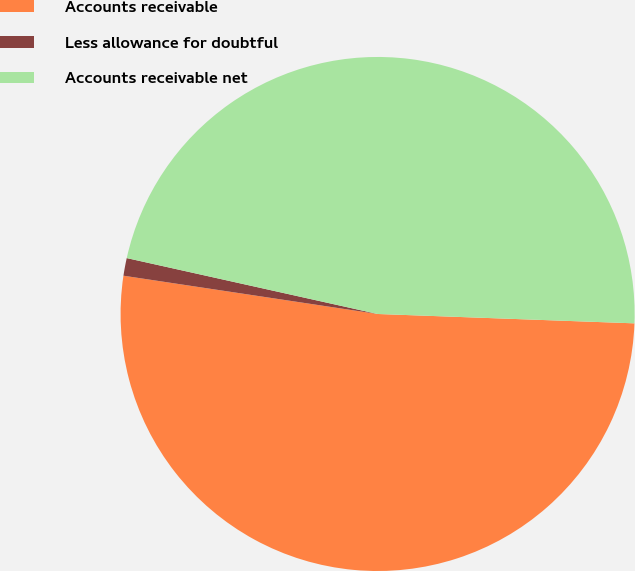Convert chart. <chart><loc_0><loc_0><loc_500><loc_500><pie_chart><fcel>Accounts receivable<fcel>Less allowance for doubtful<fcel>Accounts receivable net<nl><fcel>51.8%<fcel>1.11%<fcel>47.09%<nl></chart> 